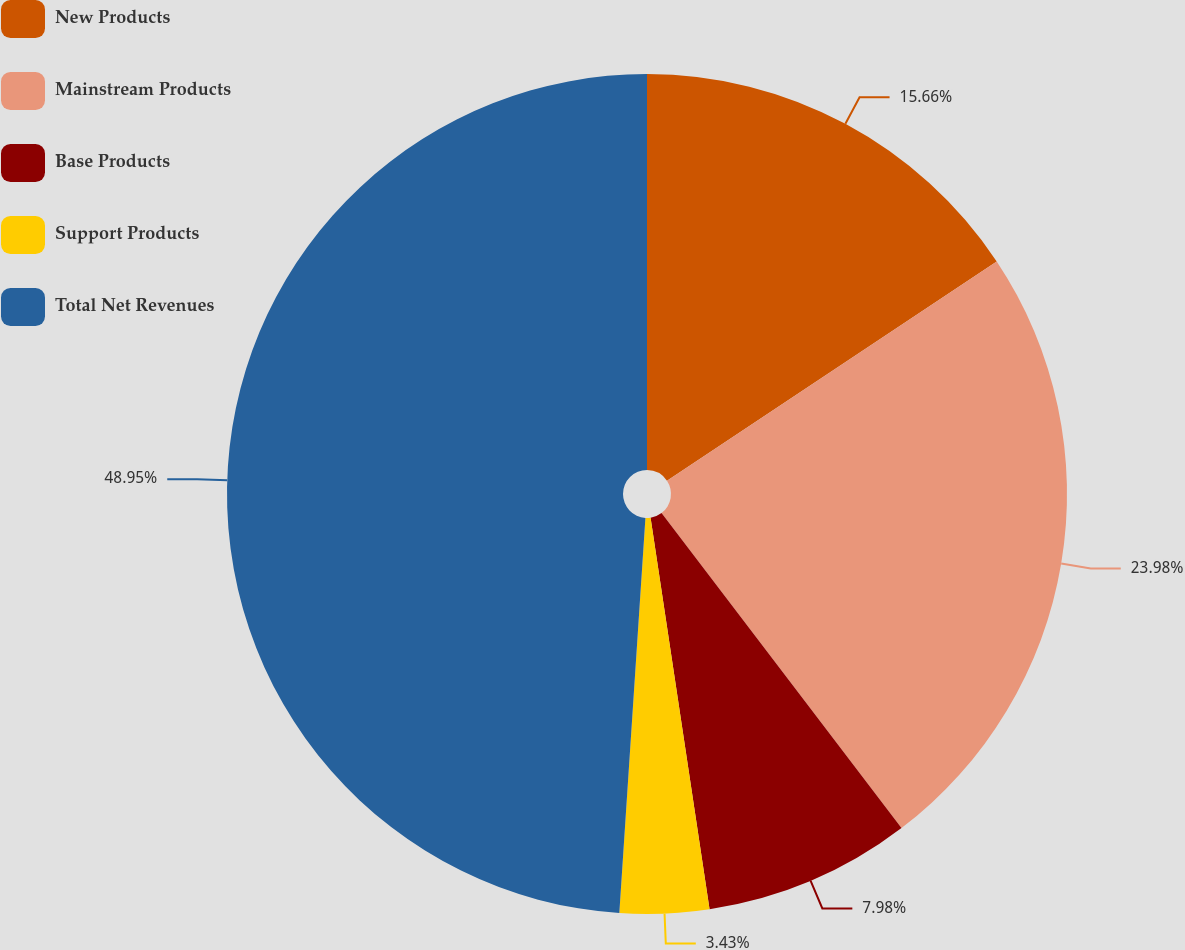<chart> <loc_0><loc_0><loc_500><loc_500><pie_chart><fcel>New Products<fcel>Mainstream Products<fcel>Base Products<fcel>Support Products<fcel>Total Net Revenues<nl><fcel>15.66%<fcel>23.98%<fcel>7.98%<fcel>3.43%<fcel>48.95%<nl></chart> 